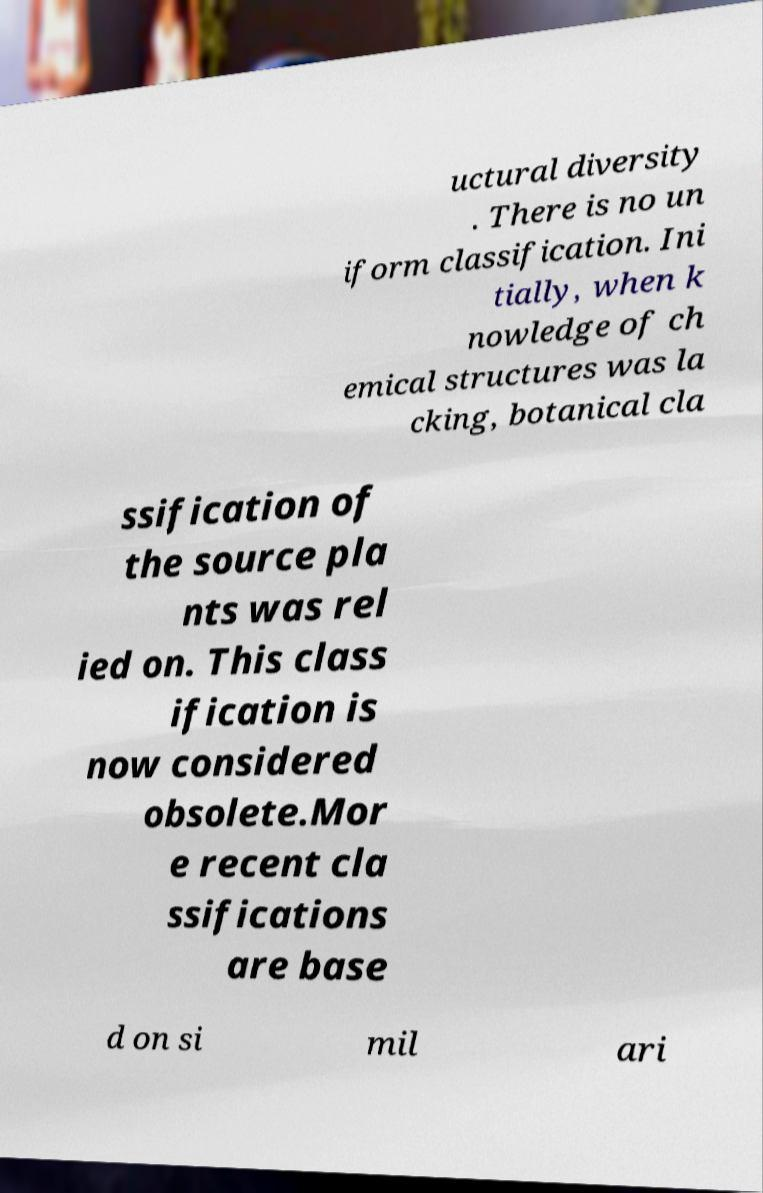Could you extract and type out the text from this image? uctural diversity . There is no un iform classification. Ini tially, when k nowledge of ch emical structures was la cking, botanical cla ssification of the source pla nts was rel ied on. This class ification is now considered obsolete.Mor e recent cla ssifications are base d on si mil ari 